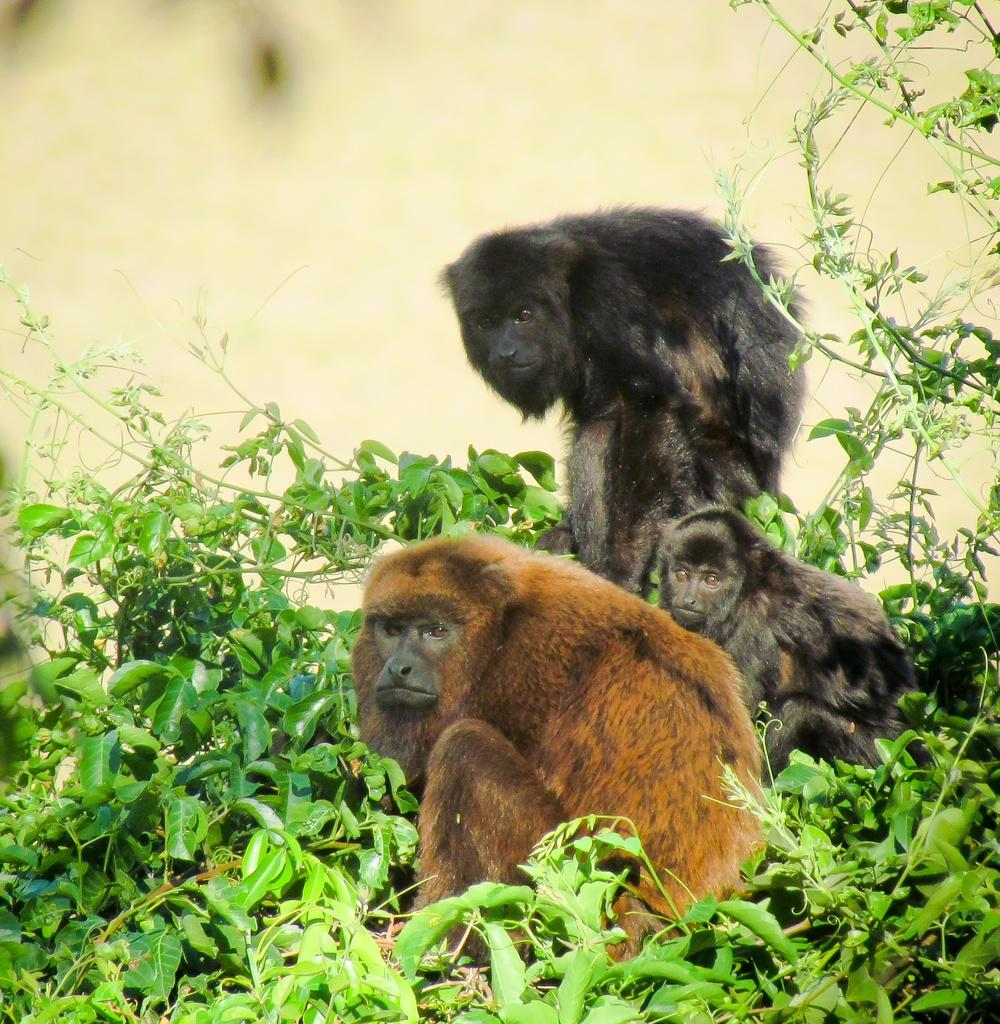How many monkeys are in the image? There are three monkeys in the image. What colors are the monkeys? One monkey is brown in color, and two monkeys are black in color. What else can be seen in the image besides the monkeys? There are plants in the image. Can you describe the background of the image? The background of the image is blurred. What time of day is it in the image, and what substance is the porter carrying? There is no indication of time of day in the image, and there is no porter present carrying any substance. 